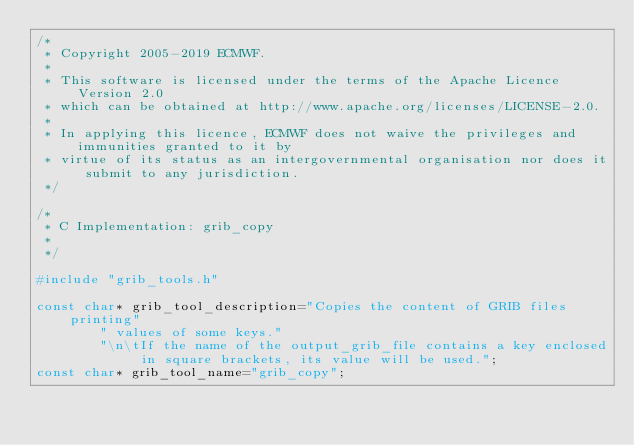<code> <loc_0><loc_0><loc_500><loc_500><_C_>/*
 * Copyright 2005-2019 ECMWF.
 *
 * This software is licensed under the terms of the Apache Licence Version 2.0
 * which can be obtained at http://www.apache.org/licenses/LICENSE-2.0.
 *
 * In applying this licence, ECMWF does not waive the privileges and immunities granted to it by
 * virtue of its status as an intergovernmental organisation nor does it submit to any jurisdiction.
 */

/*
 * C Implementation: grib_copy
 *
 */

#include "grib_tools.h"

const char* grib_tool_description="Copies the content of GRIB files printing"
        " values of some keys."
        "\n\tIf the name of the output_grib_file contains a key enclosed in square brackets, its value will be used.";
const char* grib_tool_name="grib_copy";</code> 